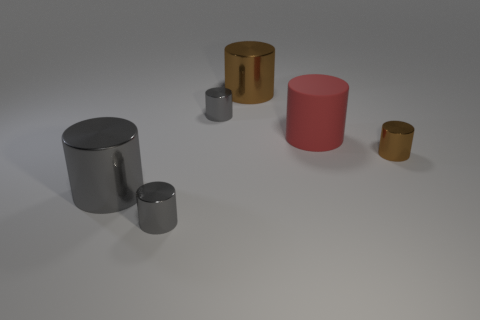How many gray cylinders must be subtracted to get 1 gray cylinders? 2 Subtract all green cubes. How many gray cylinders are left? 3 Subtract all brown cylinders. How many cylinders are left? 4 Subtract all large red rubber cylinders. How many cylinders are left? 5 Subtract all blue cylinders. Subtract all yellow balls. How many cylinders are left? 6 Add 3 brown shiny things. How many objects exist? 9 Subtract 0 brown blocks. How many objects are left? 6 Subtract all small brown metal things. Subtract all red matte objects. How many objects are left? 4 Add 2 big cylinders. How many big cylinders are left? 5 Add 1 tiny cyan matte cylinders. How many tiny cyan matte cylinders exist? 1 